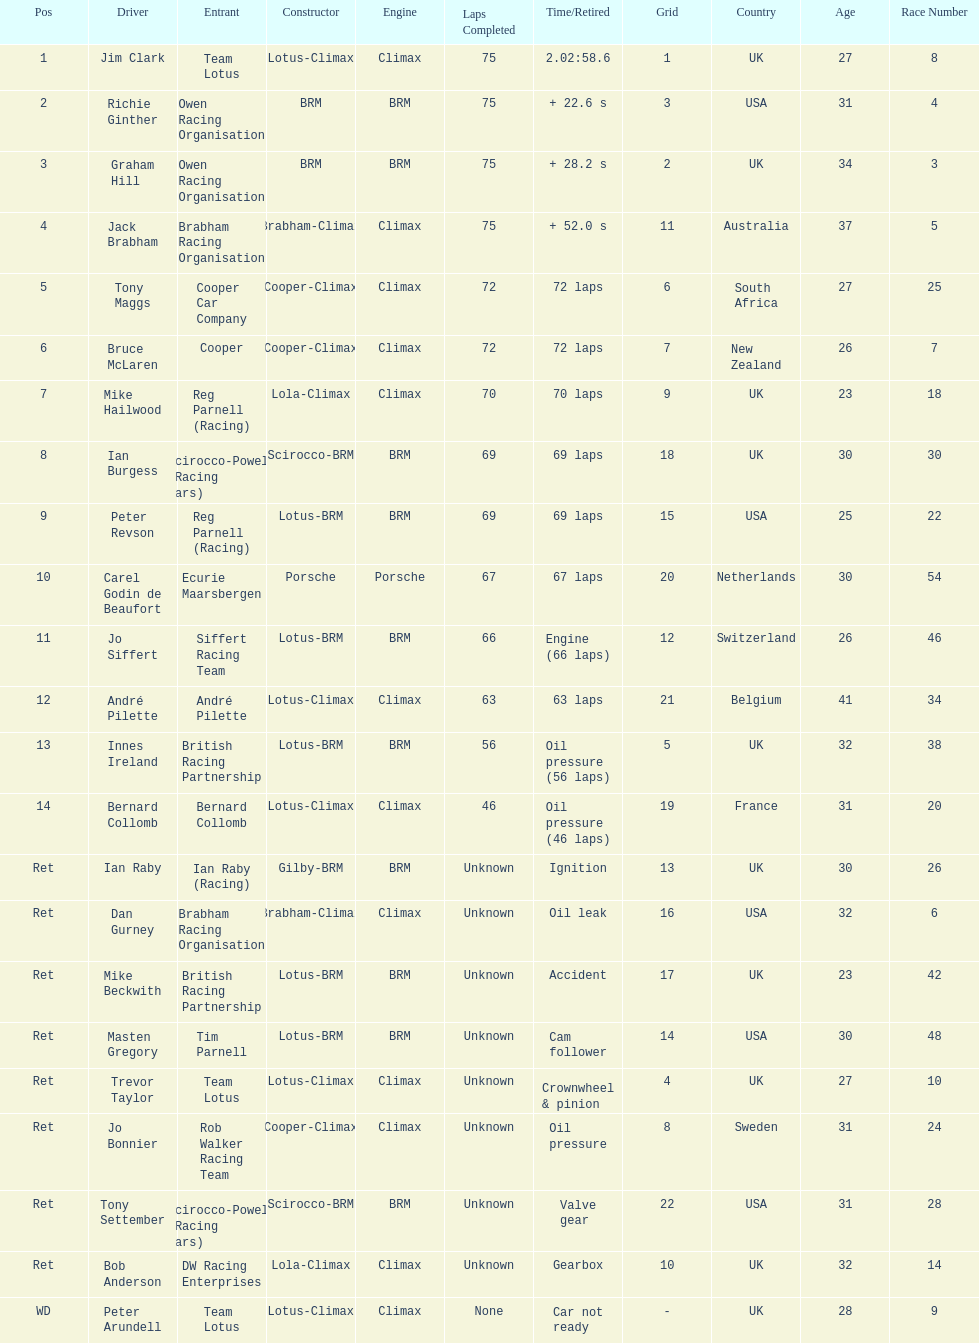Who came in first? Jim Clark. 